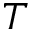<formula> <loc_0><loc_0><loc_500><loc_500>T</formula> 